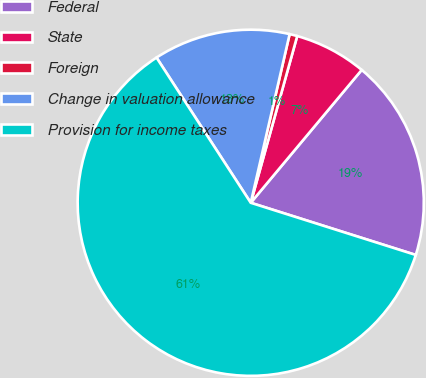Convert chart to OTSL. <chart><loc_0><loc_0><loc_500><loc_500><pie_chart><fcel>Federal<fcel>State<fcel>Foreign<fcel>Change in valuation allowance<fcel>Provision for income taxes<nl><fcel>18.8%<fcel>6.75%<fcel>0.72%<fcel>12.77%<fcel>60.97%<nl></chart> 